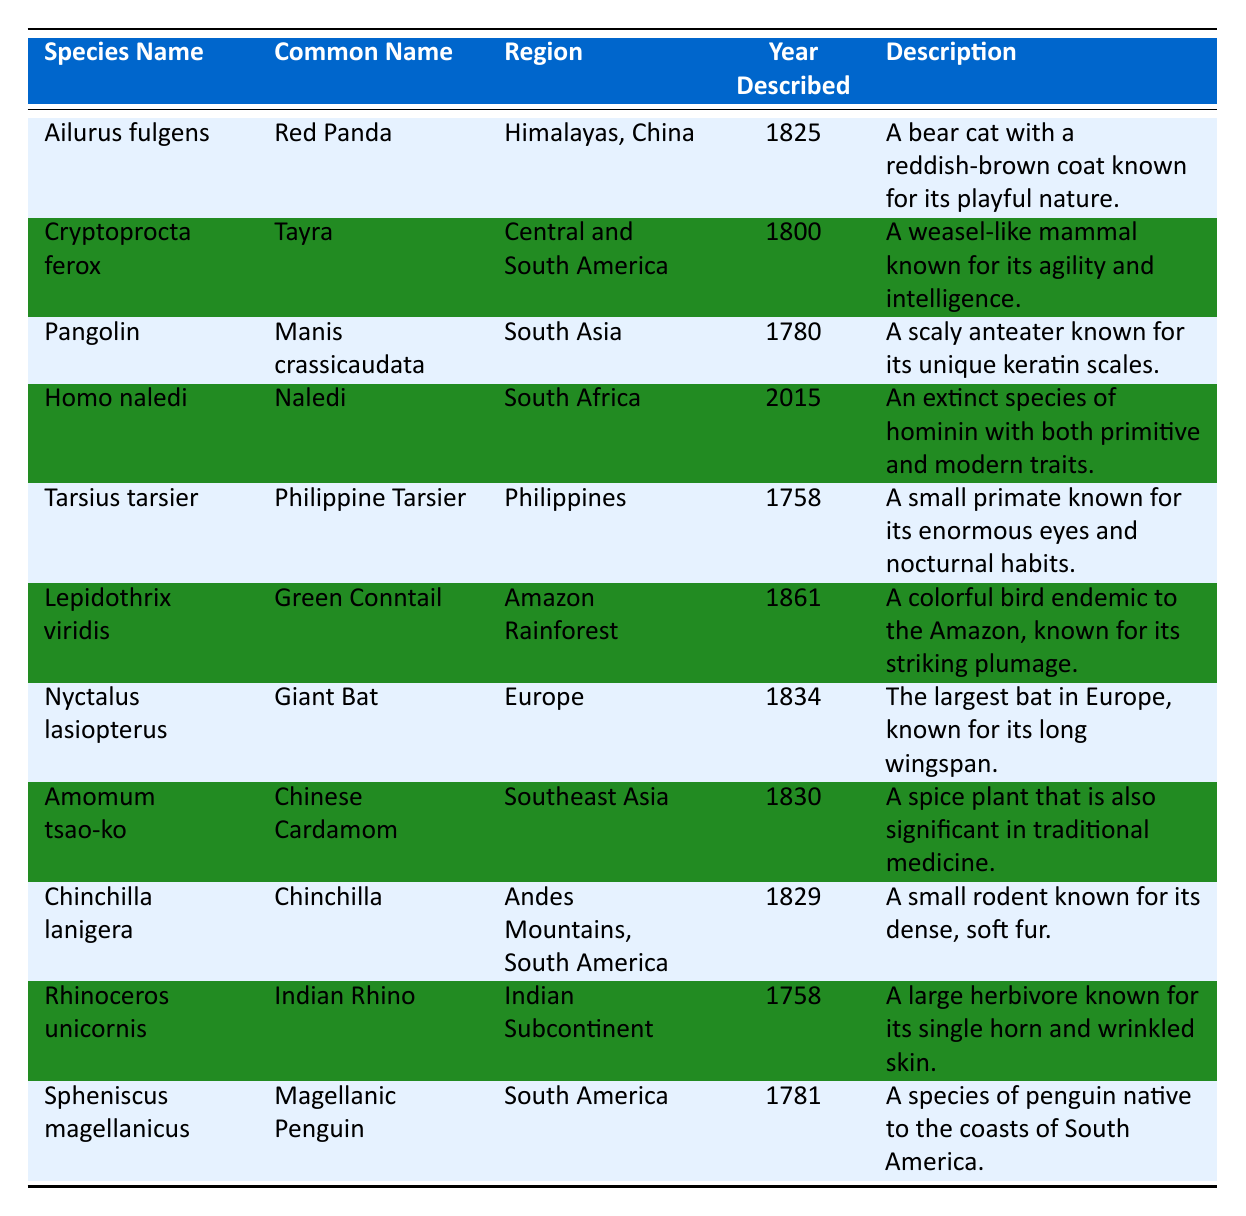What is the common name of the species described in 2015? The only species described in 2015 in the table is "Homo naledi," which has the common name "Naledi."
Answer: Naledi In which region is the "Green Conntail" found? The "Green Conntail," known scientifically as "Lepidothrix viridis," is found in the Amazon Rainforest as indicated in the region column of the table.
Answer: Amazon Rainforest How many species have a year of description earlier than 1800? The table lists four species described before 1800: "Tayra" (1800), "Pangolin" (1780), "Spheniscus magellanicus" (1781), and "Rhinoceros unicornis" (1758), which makes a total of 6 species (including Pangolin). Therefore, the count of species earlier than 1800 is 6.
Answer: 6 Is the "Indian Rhino" native to Africa? The "Indian Rhino," also known as "Rhinoceros unicornis," is actually native to the Indian Subcontinent, not Africa, as the table specifies in the region column.
Answer: No What is the average year of description for the species listed from the Americas? The species listed from the Americas are "Tayra" (1800), "Spheniscus magellanicus" (1781), "Chinchilla" (1829), and "Lepidothrix viridis" (1861). Adding their years gives: 1800 + 1781 + 1829 + 1861 = 7251. There are 4 species, so the average year is 7251 / 4 = 1812.75, which can be rounded to 1813.
Answer: 1813 Which species has a description including the term "eyes"? The species "Tarsius tarsier," known as "Philippine Tarsier," has the description mentioning "enormous eyes," thus fulfilling the requirement.
Answer: Philippine Tarsier 